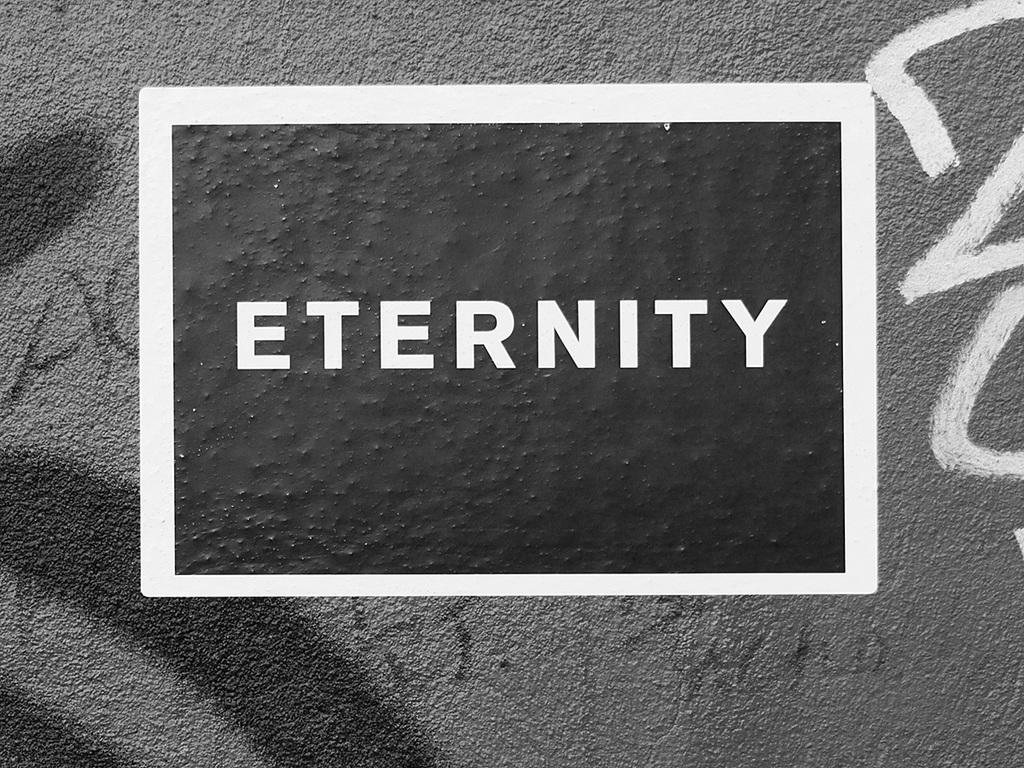<image>
Offer a succinct explanation of the picture presented. A black and white frame with the word eternity on a stone wall. 